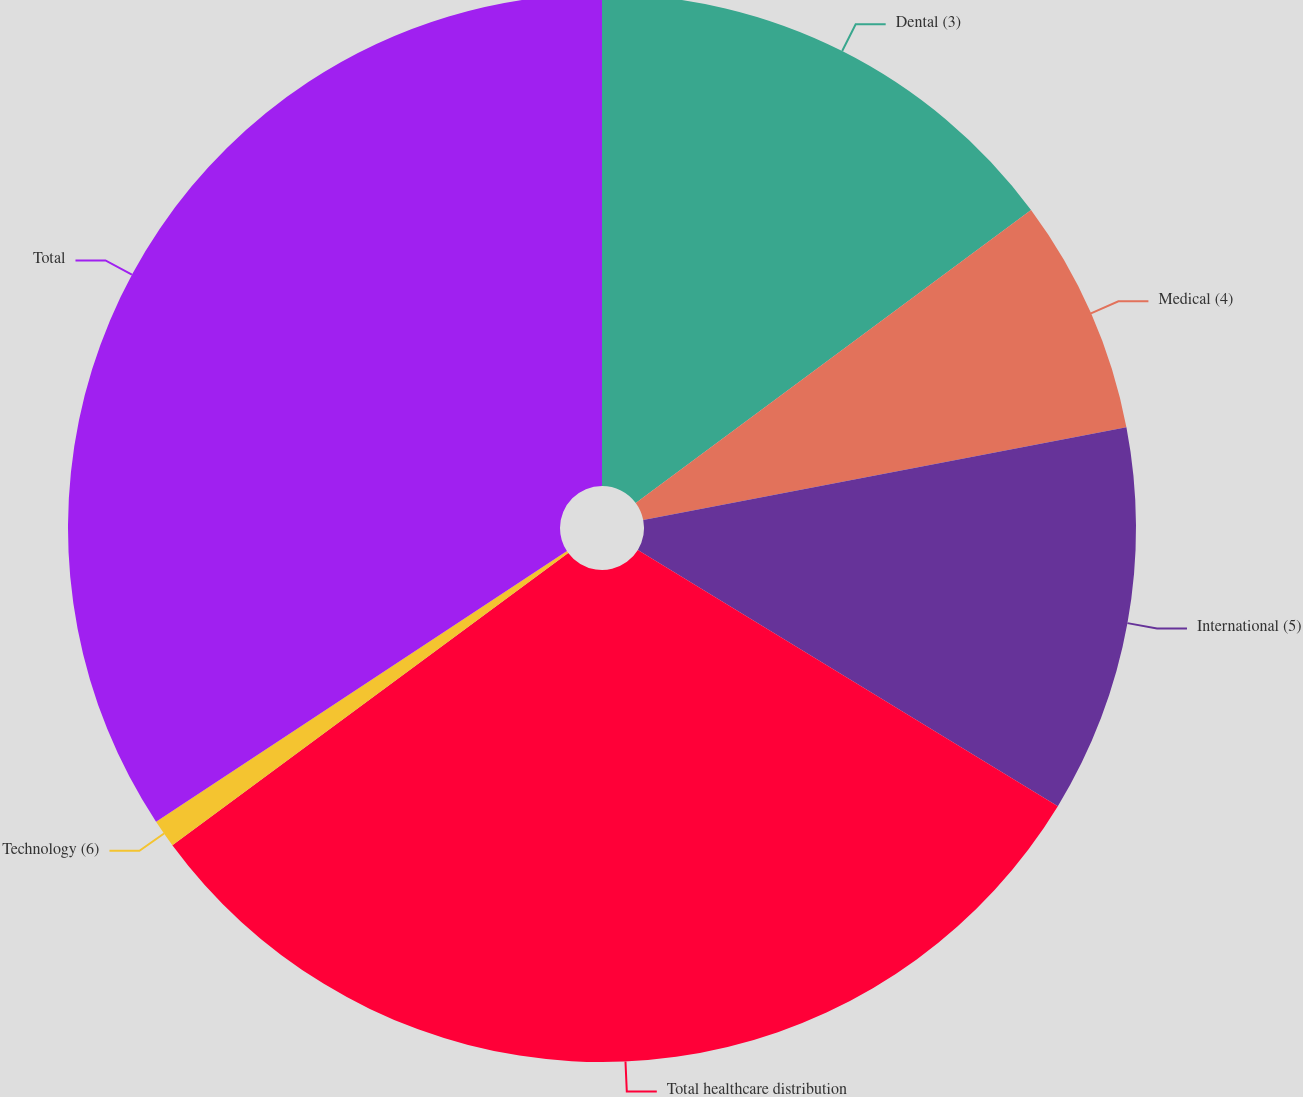Convert chart to OTSL. <chart><loc_0><loc_0><loc_500><loc_500><pie_chart><fcel>Dental (3)<fcel>Medical (4)<fcel>International (5)<fcel>Total healthcare distribution<fcel>Technology (6)<fcel>Total<nl><fcel>14.85%<fcel>7.13%<fcel>11.74%<fcel>31.16%<fcel>0.85%<fcel>34.27%<nl></chart> 